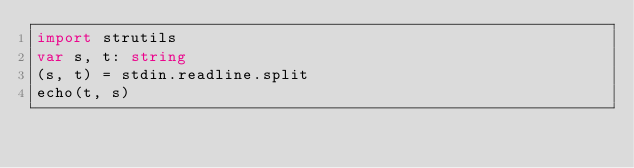Convert code to text. <code><loc_0><loc_0><loc_500><loc_500><_Nim_>import strutils
var s, t: string
(s, t) = stdin.readline.split
echo(t, s)</code> 